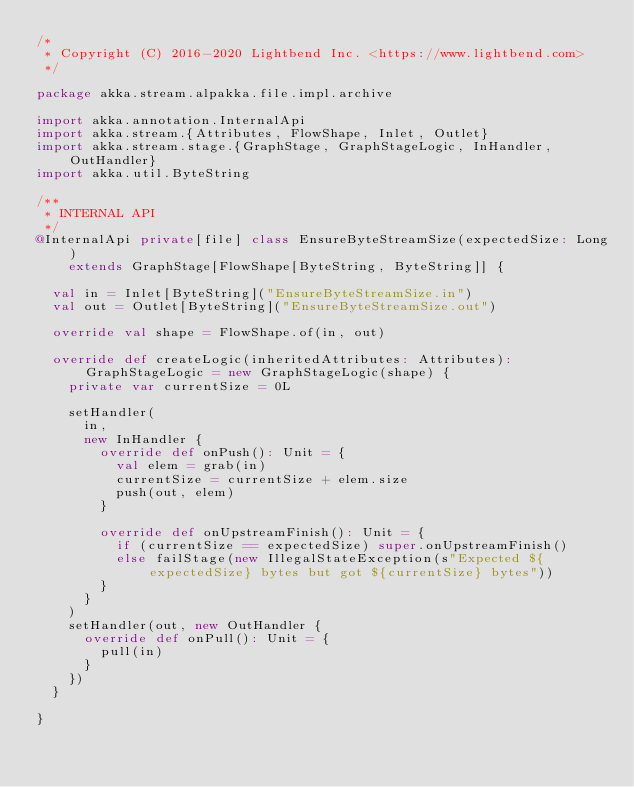<code> <loc_0><loc_0><loc_500><loc_500><_Scala_>/*
 * Copyright (C) 2016-2020 Lightbend Inc. <https://www.lightbend.com>
 */

package akka.stream.alpakka.file.impl.archive

import akka.annotation.InternalApi
import akka.stream.{Attributes, FlowShape, Inlet, Outlet}
import akka.stream.stage.{GraphStage, GraphStageLogic, InHandler, OutHandler}
import akka.util.ByteString

/**
 * INTERNAL API
 */
@InternalApi private[file] class EnsureByteStreamSize(expectedSize: Long)
    extends GraphStage[FlowShape[ByteString, ByteString]] {

  val in = Inlet[ByteString]("EnsureByteStreamSize.in")
  val out = Outlet[ByteString]("EnsureByteStreamSize.out")

  override val shape = FlowShape.of(in, out)

  override def createLogic(inheritedAttributes: Attributes): GraphStageLogic = new GraphStageLogic(shape) {
    private var currentSize = 0L

    setHandler(
      in,
      new InHandler {
        override def onPush(): Unit = {
          val elem = grab(in)
          currentSize = currentSize + elem.size
          push(out, elem)
        }

        override def onUpstreamFinish(): Unit = {
          if (currentSize == expectedSize) super.onUpstreamFinish()
          else failStage(new IllegalStateException(s"Expected ${expectedSize} bytes but got ${currentSize} bytes"))
        }
      }
    )
    setHandler(out, new OutHandler {
      override def onPull(): Unit = {
        pull(in)
      }
    })
  }

}
</code> 